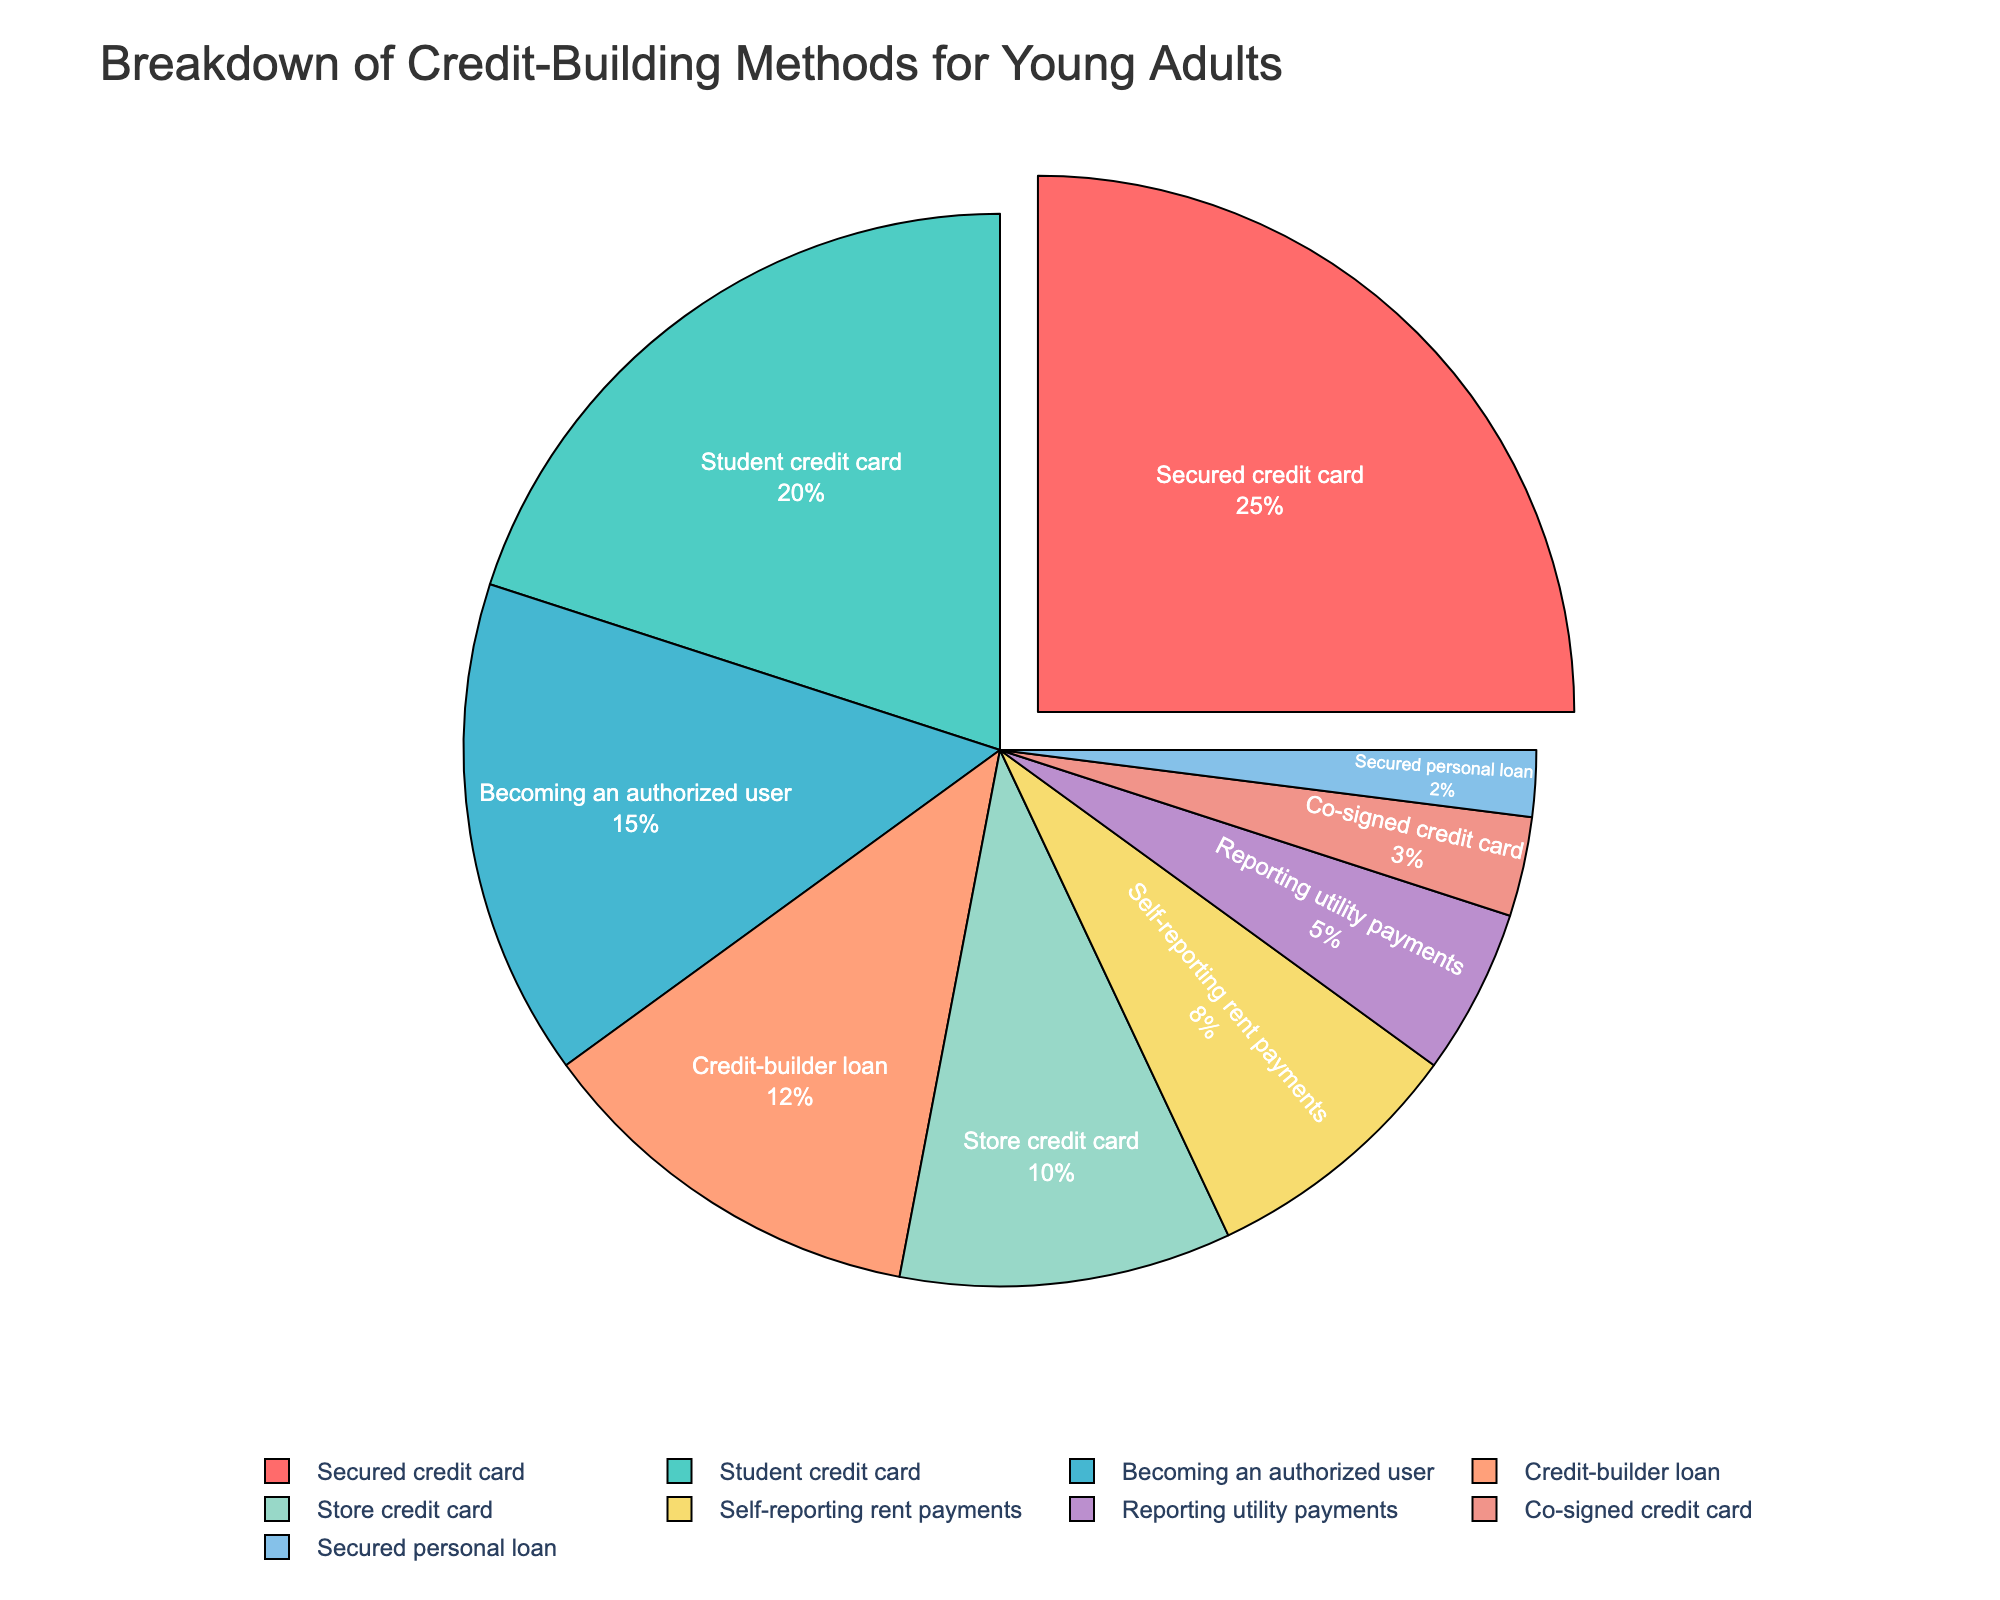What's the most common credit-building method used by young adults? The pie chart shows the proportion of each credit-building method. The segment labeled 'Secured credit card' is the largest, indicating it's the most common method.
Answer: Secured credit card Which credit-building method is the least common among young adults? By observing the pie chart, the segment 'Secured personal loan' is the smallest, thus indicating it's the least common method.
Answer: Secured personal loan What's the combined percentage of 'Secured credit card' and 'Student credit card'? The percentage for 'Secured credit card' is 25% and for 'Student credit card' is 20%. Adding these gives 25% + 20% = 45%.
Answer: 45% How does the percentage of 'Becoming an authorized user' compare to 'Credit-builder loan'? The percentage for 'Becoming an authorized user' is 15%, and for 'Credit-builder loan' it's 12%. Therefore, 'Becoming an authorized user' is higher by 3%.
Answer: Becoming an authorized user is higher What percentage of young adults use either 'Store credit card' or 'Co-signed credit card'? The percentages are 10% for 'Store credit card' and 3% for 'Co-signed credit card'. Adding these gives 10% + 3% = 13%.
Answer: 13% Which methods combined contribute more than half of the total usage? Adding the top methods: 'Secured credit card' (25%), 'Student credit card' (20%), and 'Becoming an authorized user' (15%) gives us 25% + 20% + 15% = 60%, which is more than half.
Answer: Secured credit card, Student credit card, Becoming an authorized user What are the methods with a contribution less than 10% each? The methods below 10% are 'Self-reporting rent payments' (8%), 'Reporting utility payments' (5%), 'Co-signed credit card' (3%), and 'Secured personal loan' (2%), as depicted by the smaller segments in the pie chart.
Answer: Self-reporting rent payments, Reporting utility payments, Co-signed credit card, Secured personal loan What's the difference in percentage between 'Credit-builder loan' and 'Self-reporting rent payments'? The percentage for 'Credit-builder loan' is 12% and for 'Self-reporting rent payments' is 8%. The difference is 12% - 8% = 4%.
Answer: 4% Which method represented by a blue segment has the lowest percentage? Observing the pie chart, 'Secured personal loan' is colored blue and has the lowest percentage among the blue segments.
Answer: Secured personal loan Based on the pie chart, how much more popular is 'Student credit card' compared to 'Store credit card'? The 'Student credit card' has a percentage of 20%, and the 'Store credit card' has 10%. The difference is 20% - 10% = 10%.
Answer: 10% 